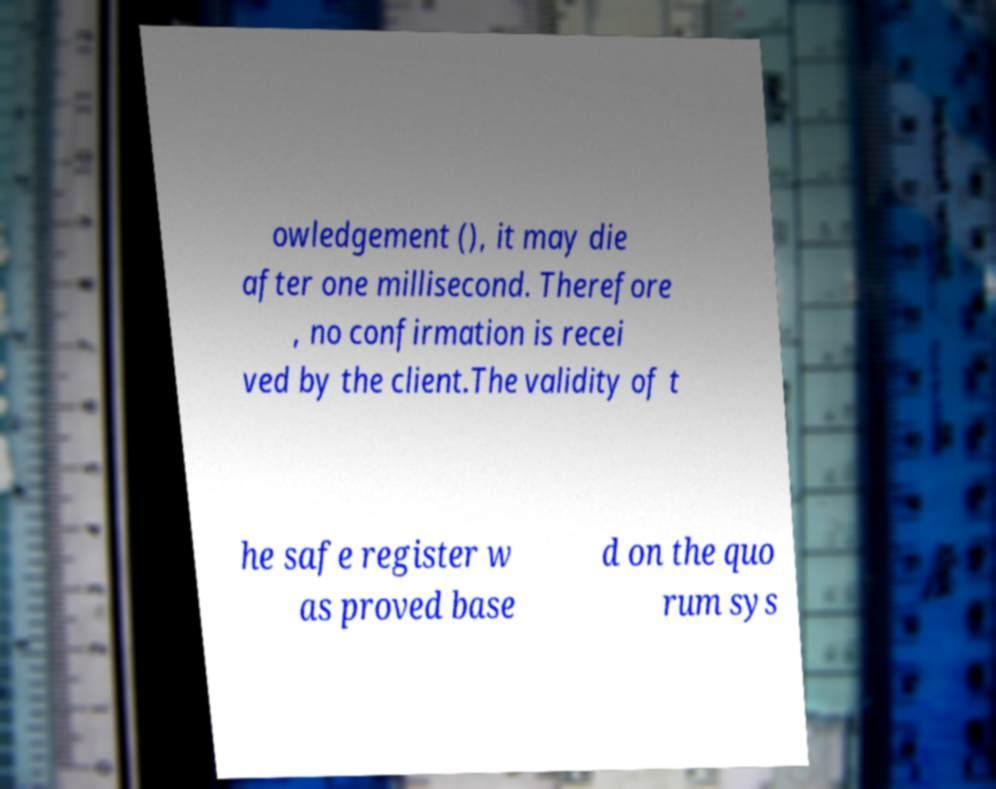Please identify and transcribe the text found in this image. owledgement (), it may die after one millisecond. Therefore , no confirmation is recei ved by the client.The validity of t he safe register w as proved base d on the quo rum sys 